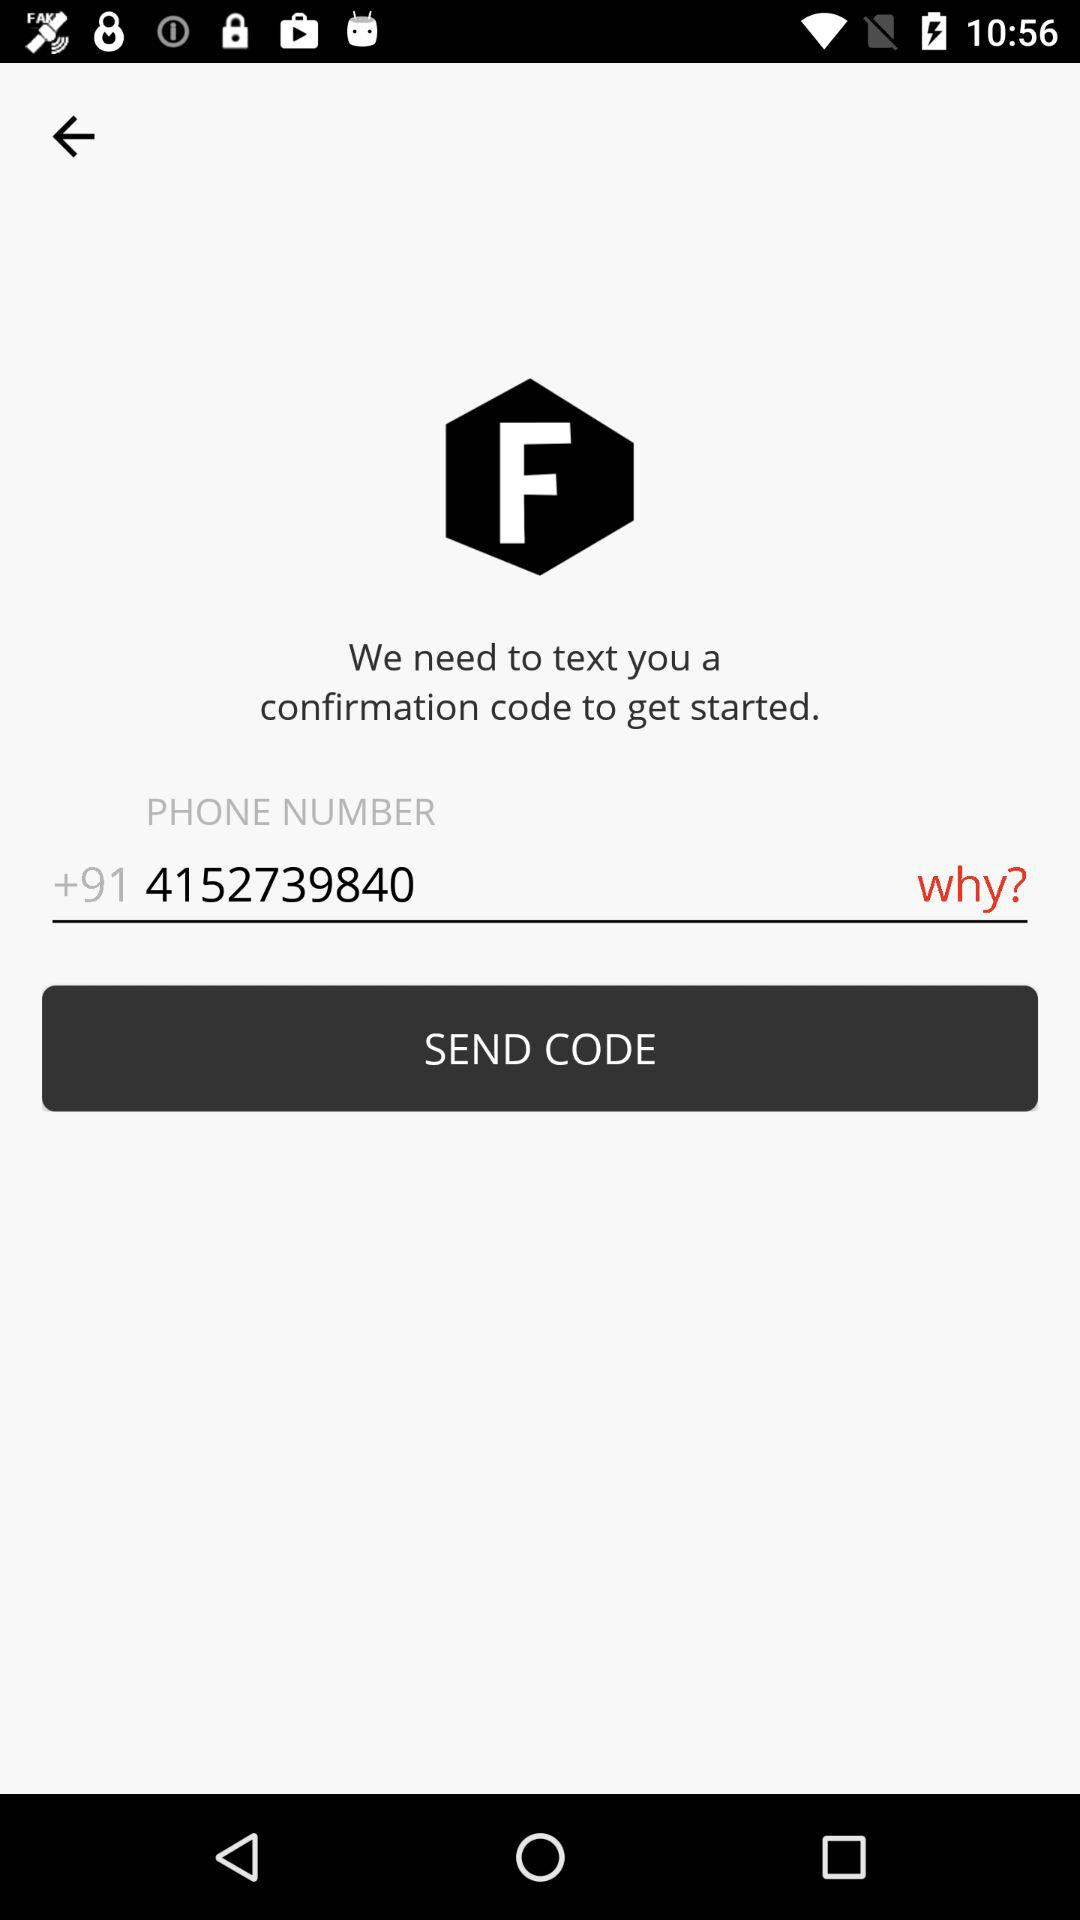What is the phone number? The phone number is +91 4152739840. 